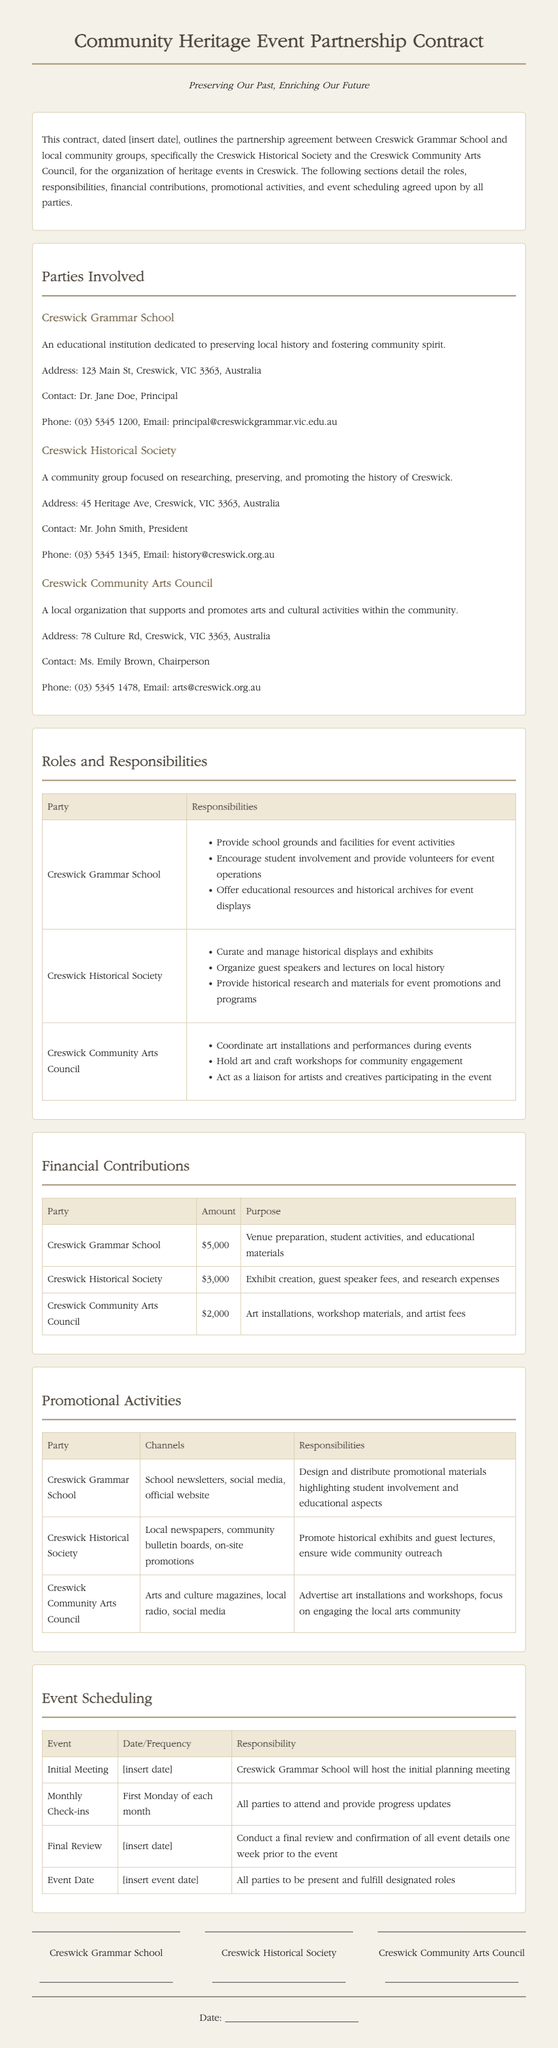what is the purpose of the contract? The purpose of the contract is to outline the partnership agreement between Creswick Grammar School and local community groups for organizing heritage events.
Answer: Partnership agreement for organizing heritage events who is the contact for Creswick Grammar School? The document provides the name of the principal as the contact person for Creswick Grammar School.
Answer: Dr. Jane Doe how much is the financial contribution from the Creswick Historical Society? The amount contributed by the Creswick Historical Society is listed in the financial contributions table.
Answer: $3,000 what is the frequency of the monthly check-ins? The document specifies when the monthly check-ins will occur, which is a regular schedule.
Answer: First Monday of each month which organization is responsible for coordinating art installations? The role of coordinating art installations is mentioned in the responsibilities section for one of the organizations.
Answer: Creswick Community Arts Council what type of activities will Creswick Grammar School's contribution be used for? The purposes for the contribution from Creswick Grammar School are specified in the financial contributions table.
Answer: Venue preparation, student activities, and educational materials when will the final review take place? The document details the timing for the final review of the event plans.
Answer: One week prior to the event what promotional channels will the Creswick Community Arts Council use? The document outlines specific channels for promotion used by each party.
Answer: Arts and culture magazines, local radio, social media what are the responsibilities listed for the Creswick Historical Society? The specific responsibilities assigned to the Creswick Historical Society are mentioned in the roles and responsibilities table.
Answer: Curate and manage historical displays and exhibits 